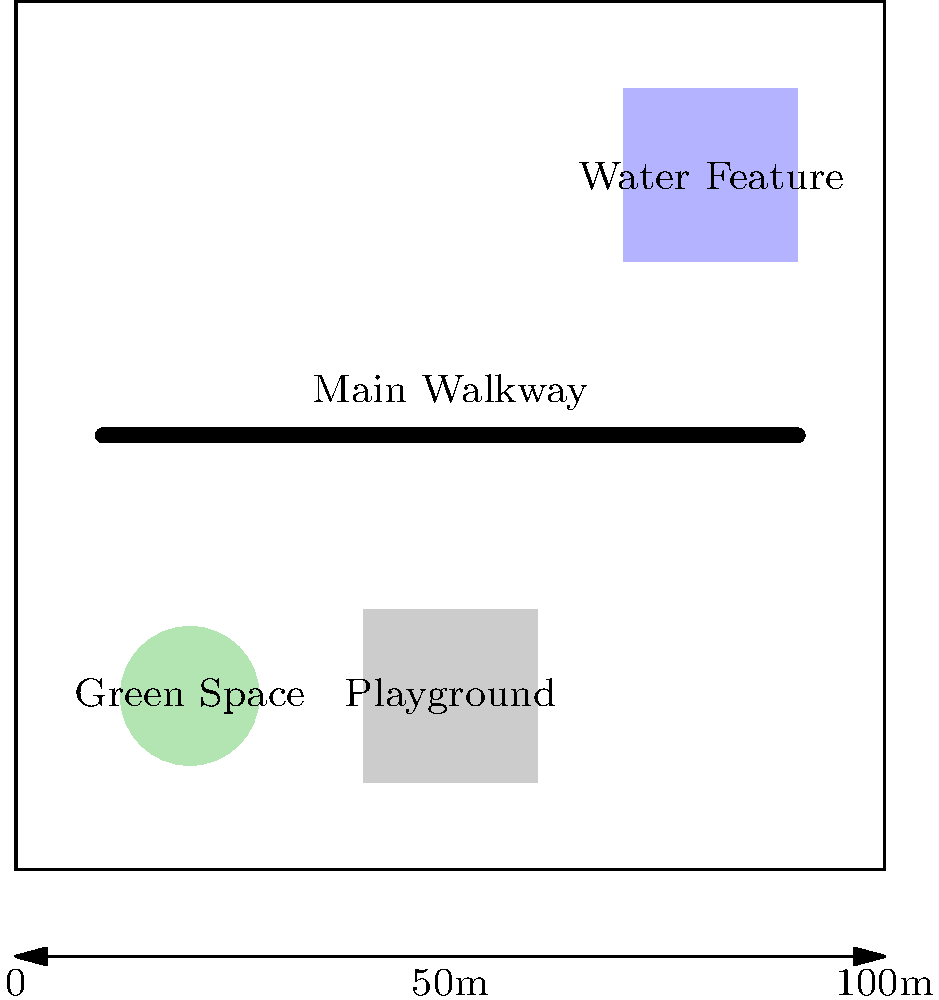Given the layout of a proposed 100m x 100m public park shown above, which feature placement could be adjusted to improve overall efficiency and accessibility for park visitors? To determine the most efficient layout, we need to consider several factors:

1. Accessibility: The main walkway should connect all major features for easy access.
2. Space utilization: Features should be spread out to maximize usable space.
3. Flow: The layout should promote smooth movement of visitors throughout the park.
4. Safety: Children's areas should be easily supervised and away from potential hazards.

Analyzing the current layout:

1. The green space is well-placed near the entrance (bottom-left), providing an open area for various activities.
2. The playground is centrally located, which is good for accessibility.
3. The water feature is isolated in the top-right corner, making it less accessible.
4. The main walkway only connects the green space and playground, neglecting the water feature.

The most significant improvement would be to relocate the water feature closer to the main walkway. This would:

1. Improve accessibility to all major features.
2. Create a more balanced distribution of attractions throughout the park.
3. Enhance the overall flow of visitors.
4. Potentially increase usage of the water feature.

A suggested location would be the area between the playground and the current water feature position, adjacent to the main walkway.
Answer: Relocate water feature closer to main walkway 